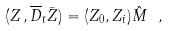<formula> <loc_0><loc_0><loc_500><loc_500>( Z \, , { \overline { D } } _ { \bar { \imath } } \bar { Z } ) = ( Z _ { 0 } , Z _ { i } ) \hat { M } \ ,</formula> 